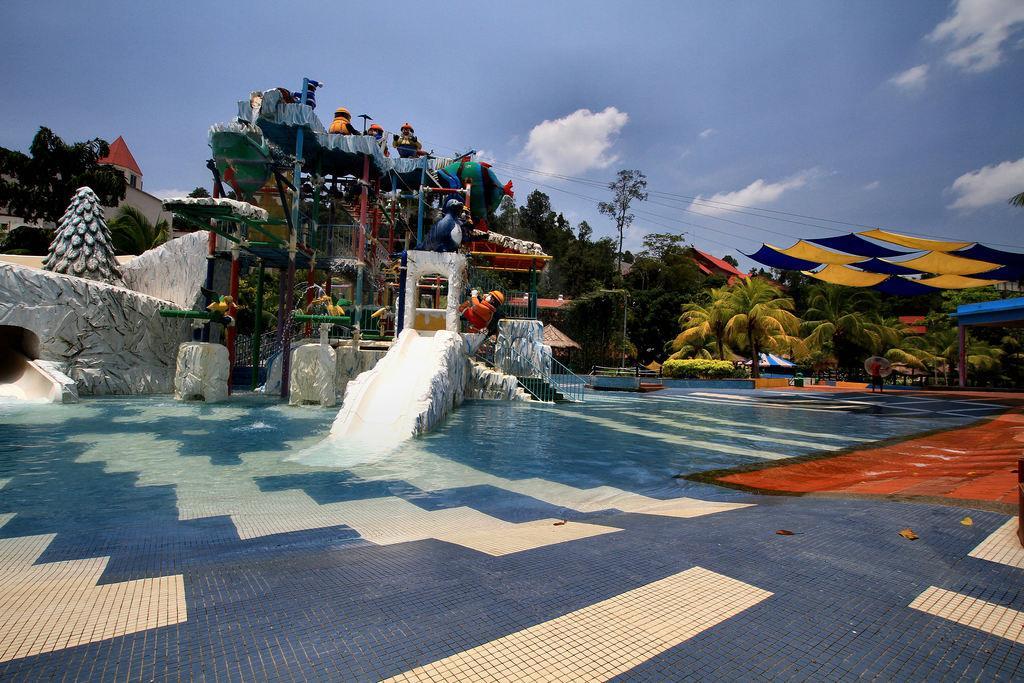Describe this image in one or two sentences. In this image I can see water, few water rides, number of trees, few wire, few buildings and on the right side I can see few colourful things. In the background I can see clouds and the sky. 